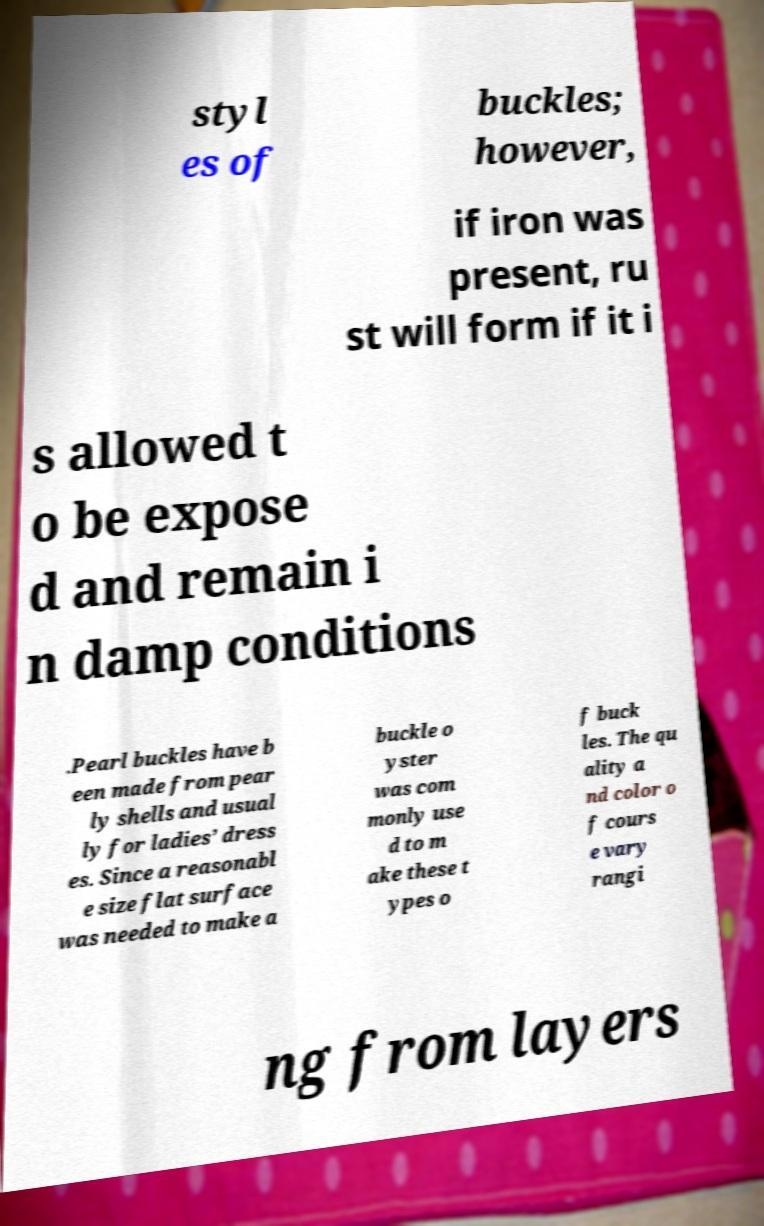Can you accurately transcribe the text from the provided image for me? styl es of buckles; however, if iron was present, ru st will form if it i s allowed t o be expose d and remain i n damp conditions .Pearl buckles have b een made from pear ly shells and usual ly for ladies’ dress es. Since a reasonabl e size flat surface was needed to make a buckle o yster was com monly use d to m ake these t ypes o f buck les. The qu ality a nd color o f cours e vary rangi ng from layers 